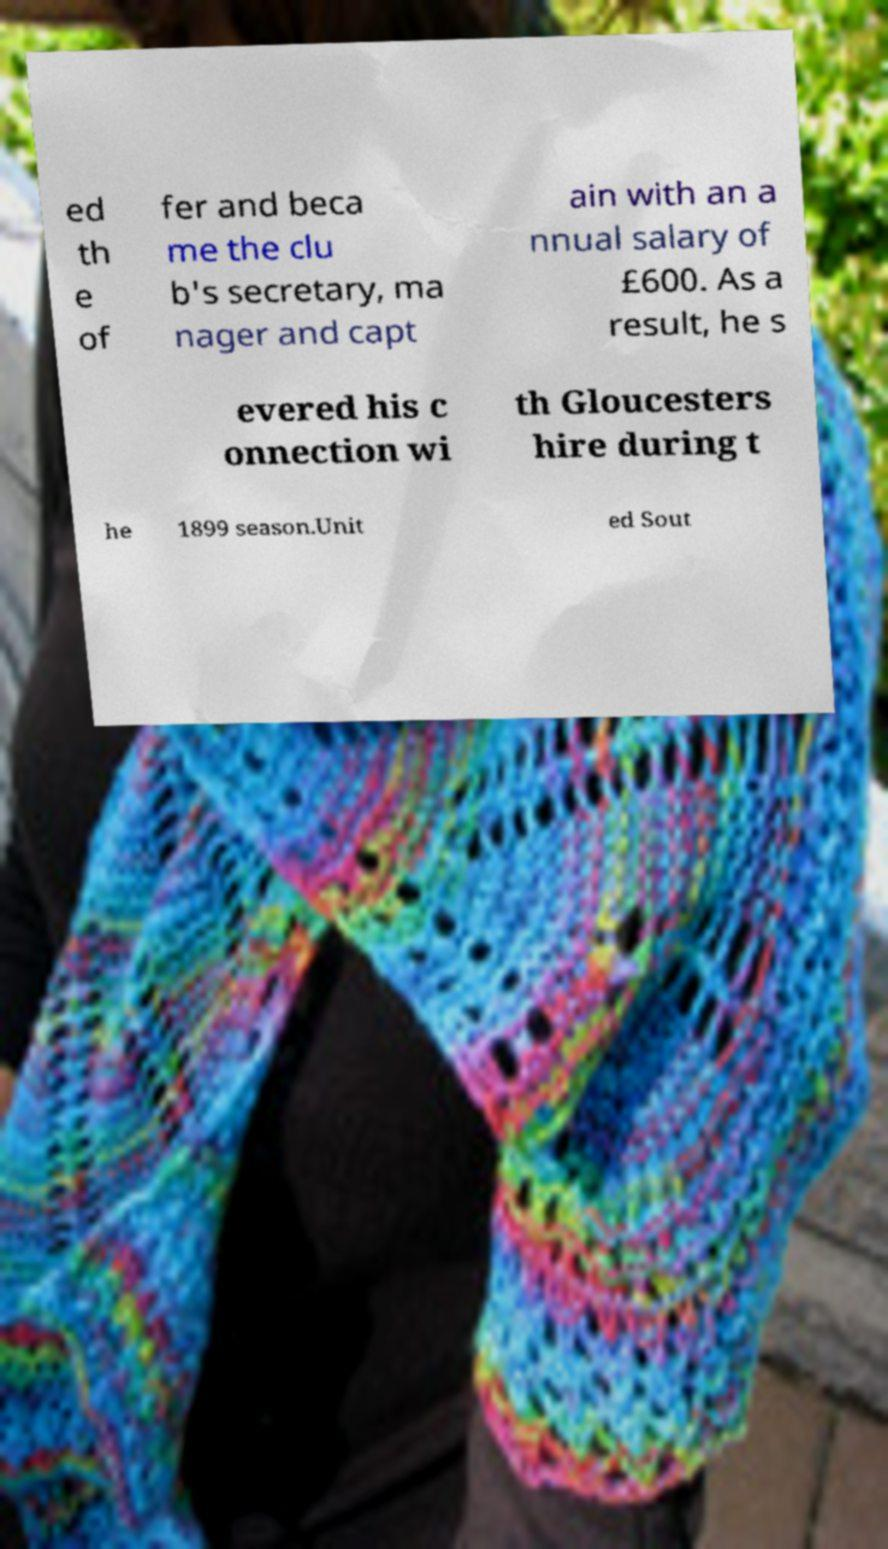For documentation purposes, I need the text within this image transcribed. Could you provide that? ed th e of fer and beca me the clu b's secretary, ma nager and capt ain with an a nnual salary of £600. As a result, he s evered his c onnection wi th Gloucesters hire during t he 1899 season.Unit ed Sout 